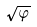<formula> <loc_0><loc_0><loc_500><loc_500>\sqrt { \varphi }</formula> 